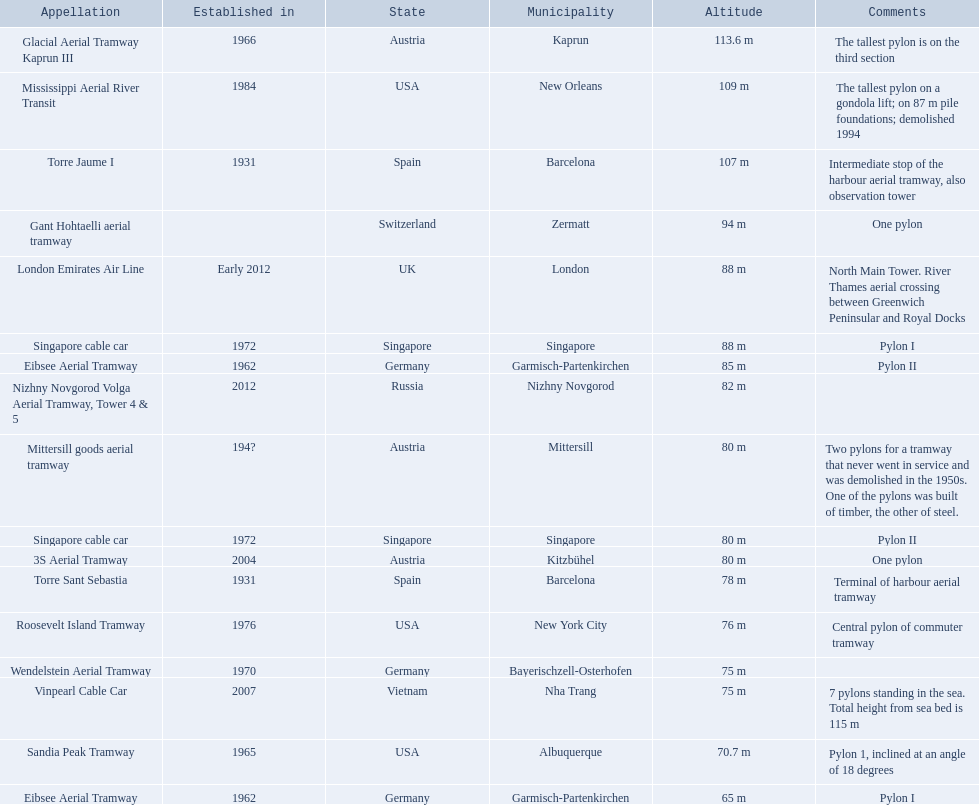Which lift has the second highest height? Mississippi Aerial River Transit. What is the value of the height? 109 m. 